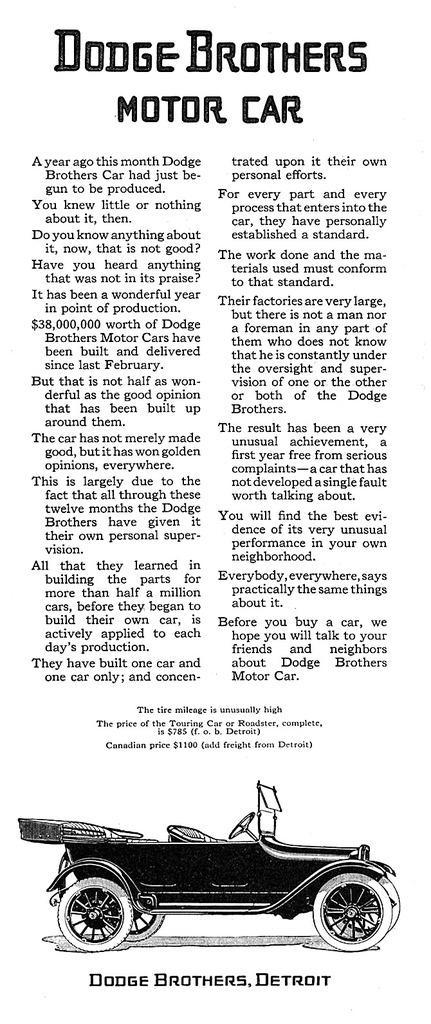Could you give a brief overview of what you see in this image? In this image I can see a paper, on the paper I can see a vehicle and something written on the paper. 